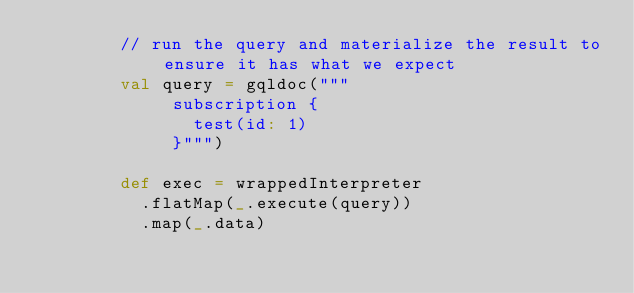Convert code to text. <code><loc_0><loc_0><loc_500><loc_500><_Scala_>        // run the query and materialize the result to ensure it has what we expect
        val query = gqldoc("""
             subscription {
               test(id: 1)
             }""")

        def exec = wrappedInterpreter
          .flatMap(_.execute(query))
          .map(_.data)</code> 